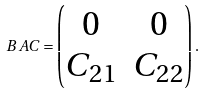<formula> <loc_0><loc_0><loc_500><loc_500>B A C = \begin{pmatrix} 0 & 0 \\ C _ { 2 1 } & C _ { 2 2 } \end{pmatrix} .</formula> 